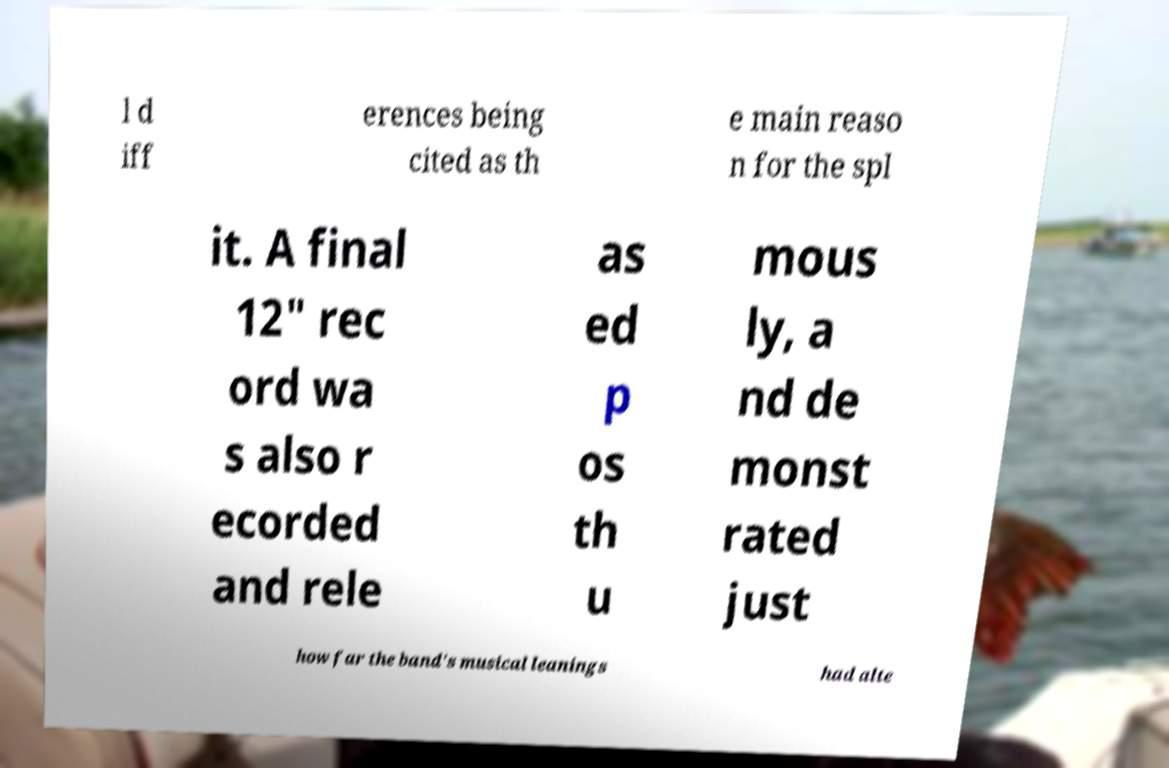Please identify and transcribe the text found in this image. l d iff erences being cited as th e main reaso n for the spl it. A final 12" rec ord wa s also r ecorded and rele as ed p os th u mous ly, a nd de monst rated just how far the band's musical leanings had alte 